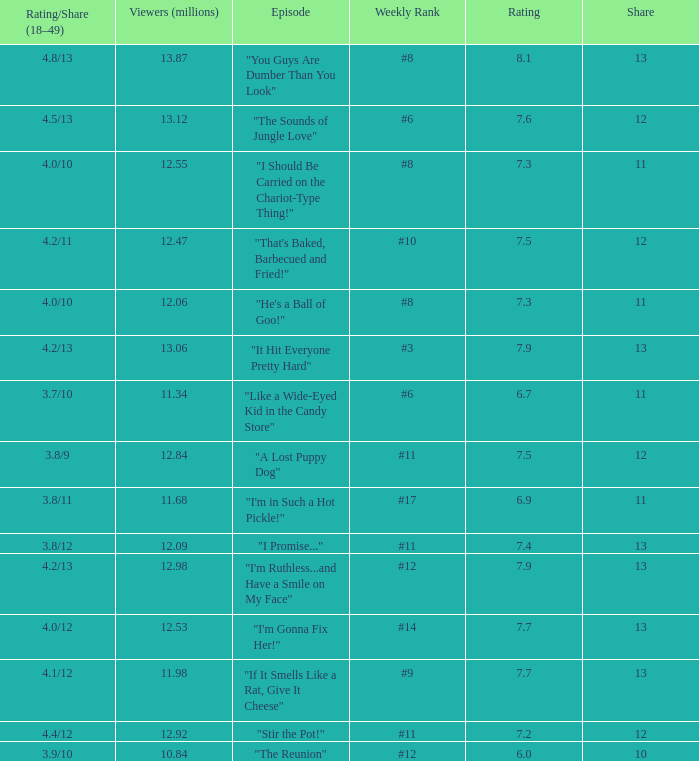What is the average rating for "a lost puppy dog"? 7.5. Give me the full table as a dictionary. {'header': ['Rating/Share (18–49)', 'Viewers (millions)', 'Episode', 'Weekly Rank', 'Rating', 'Share'], 'rows': [['4.8/13', '13.87', '"You Guys Are Dumber Than You Look"', '#8', '8.1', '13'], ['4.5/13', '13.12', '"The Sounds of Jungle Love"', '#6', '7.6', '12'], ['4.0/10', '12.55', '"I Should Be Carried on the Chariot-Type Thing!"', '#8', '7.3', '11'], ['4.2/11', '12.47', '"That\'s Baked, Barbecued and Fried!"', '#10', '7.5', '12'], ['4.0/10', '12.06', '"He\'s a Ball of Goo!"', '#8', '7.3', '11'], ['4.2/13', '13.06', '"It Hit Everyone Pretty Hard"', '#3', '7.9', '13'], ['3.7/10', '11.34', '"Like a Wide-Eyed Kid in the Candy Store"', '#6', '6.7', '11'], ['3.8/9', '12.84', '"A Lost Puppy Dog"', '#11', '7.5', '12'], ['3.8/11', '11.68', '"I\'m in Such a Hot Pickle!"', '#17', '6.9', '11'], ['3.8/12', '12.09', '"I Promise..."', '#11', '7.4', '13'], ['4.2/13', '12.98', '"I\'m Ruthless...and Have a Smile on My Face"', '#12', '7.9', '13'], ['4.0/12', '12.53', '"I\'m Gonna Fix Her!"', '#14', '7.7', '13'], ['4.1/12', '11.98', '"If It Smells Like a Rat, Give It Cheese"', '#9', '7.7', '13'], ['4.4/12', '12.92', '"Stir the Pot!"', '#11', '7.2', '12'], ['3.9/10', '10.84', '"The Reunion"', '#12', '6.0', '10']]} 